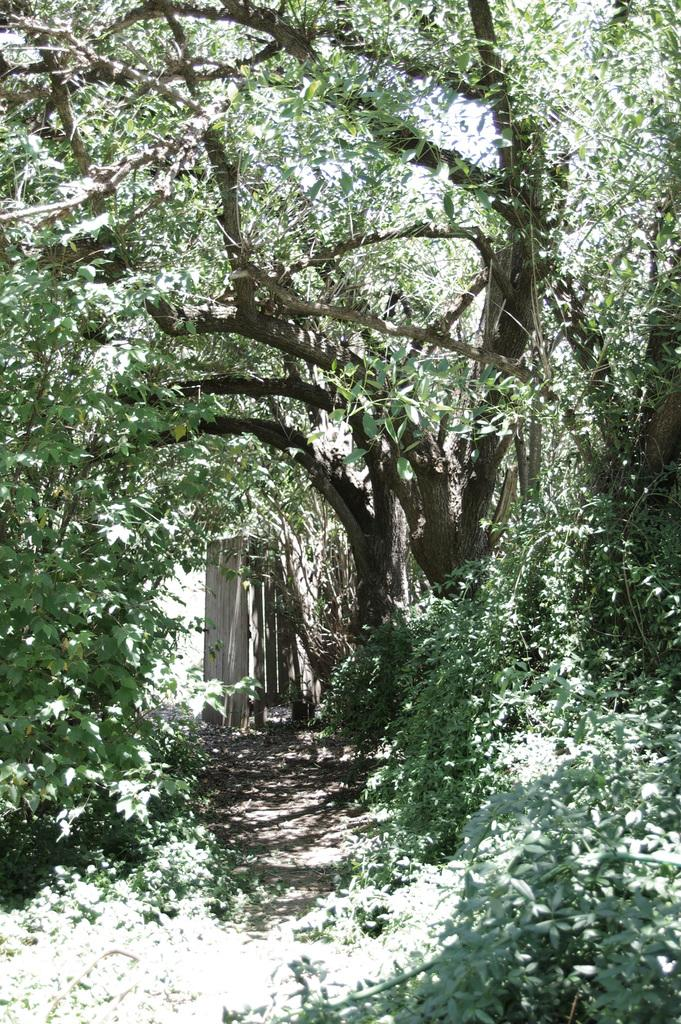What is the main feature in the center of the image? There is a path in the center of the image. What can be seen on both sides of the path? There are trees on both sides of the path. What type of fruit is hanging from the trees on both sides of the path? There is no fruit visible in the image; only trees are present on both sides of the path. 